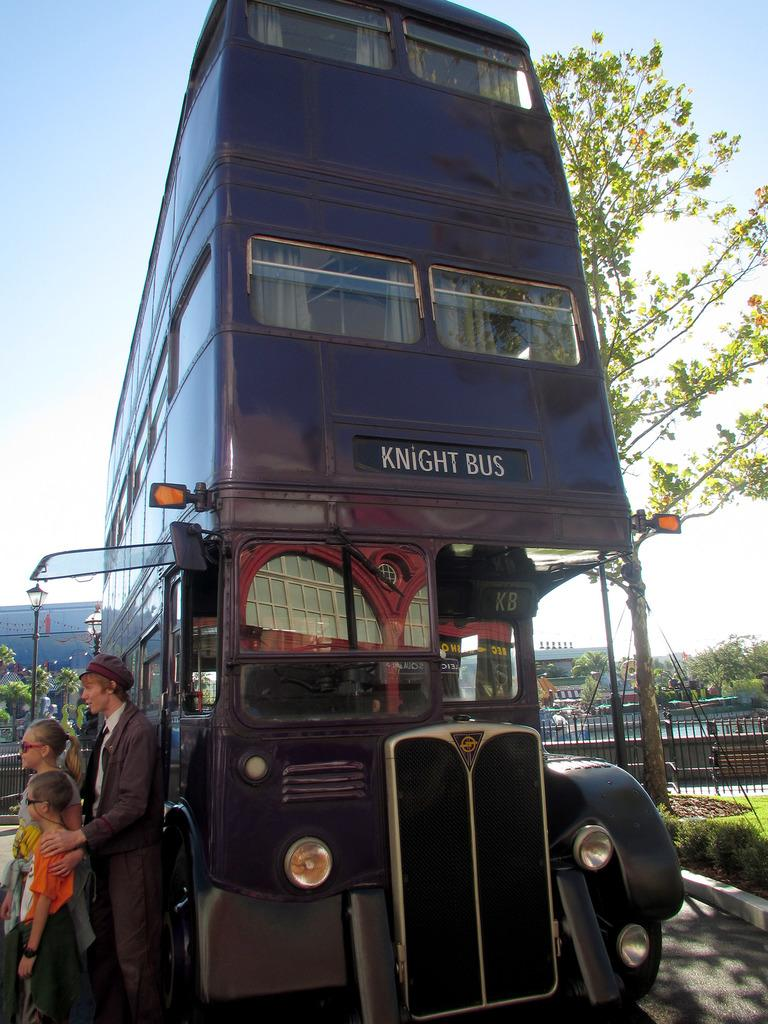What is the main subject of the image? There is a vehicle in the image. Can you describe the people in the image? There are people in the image. What can be seen in the background of the image? There is a fence, buildings, trees, grass, and sky visible in the background of the image. Are there any other objects in the background of the image? Yes, there are other objects in the background of the image. What type of rhythm can be heard coming from the vehicle in the image? There is no indication of sound or rhythm in the image, as it only shows a vehicle and people. --- Facts: 1. There is a person holding a book in the image. 2. The person is sitting on a chair. 3. There is a table in the image. 4. The table has a lamp on it. 5. There is a window in the background of the image. 6. There is a plant on the windowsill. Absurd Topics: parrot, ocean, bicycle Conversation: What is the person in the image holding? The person is holding a book in the image. Where is the person sitting? The person is sitting on a chair. What can be seen on the table in the image? There is a lamp on the table in the image. What is visible in the background of the image? There is a window and a plant on the windowsill in the background of the image. Reasoning: Let' Let's think step by step in order to produce the conversation. We start by identifying the main subject of the image, which is the person holding a book. Then, we describe the person's position, sitting on a chair. Next, we mention the table and its contents, which include a lamp. Finally, we describe the background of the image, including the window and the plant on the windowsill. Absurd Question/Answer: Can you see a parrot flying near the ocean in the image? There is no parrot or ocean present in the image; it only shows a person holding a book, sitting on a chair, a table with a lamp, and a window with a plant on the windowsill. 